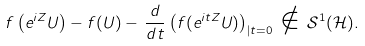Convert formula to latex. <formula><loc_0><loc_0><loc_500><loc_500>f \left ( e ^ { i Z } U \right ) - f ( U ) - \, \frac { d } { d t } \left ( f ( e ^ { i t Z } U ) \right ) _ { | t = 0 } \, \notin \, \mathcal { S } ^ { 1 } ( \mathcal { H } ) .</formula> 